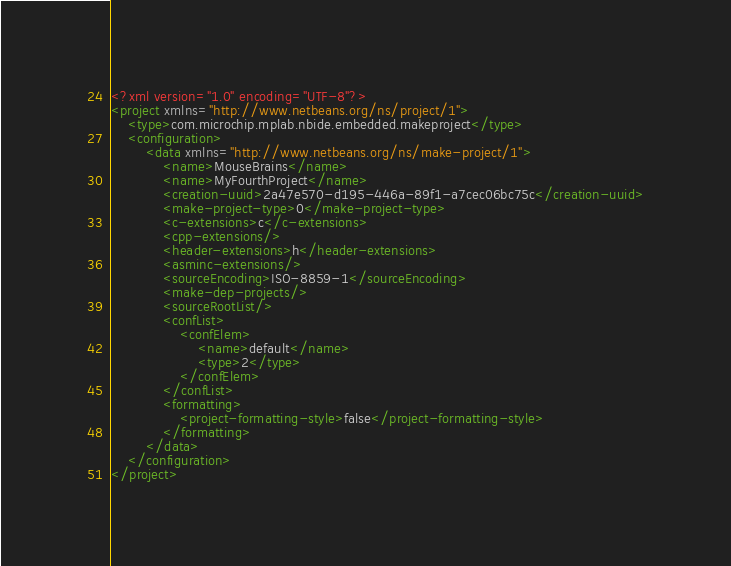<code> <loc_0><loc_0><loc_500><loc_500><_XML_><?xml version="1.0" encoding="UTF-8"?>
<project xmlns="http://www.netbeans.org/ns/project/1">
    <type>com.microchip.mplab.nbide.embedded.makeproject</type>
    <configuration>
        <data xmlns="http://www.netbeans.org/ns/make-project/1">
            <name>MouseBrains</name>
            <name>MyFourthProject</name>
            <creation-uuid>2a47e570-d195-446a-89f1-a7cec06bc75c</creation-uuid>
            <make-project-type>0</make-project-type>
            <c-extensions>c</c-extensions>
            <cpp-extensions/>
            <header-extensions>h</header-extensions>
            <asminc-extensions/>
            <sourceEncoding>ISO-8859-1</sourceEncoding>
            <make-dep-projects/>
            <sourceRootList/>
            <confList>
                <confElem>
                    <name>default</name>
                    <type>2</type>
                </confElem>
            </confList>
            <formatting>
                <project-formatting-style>false</project-formatting-style>
            </formatting>
        </data>
    </configuration>
</project>
</code> 